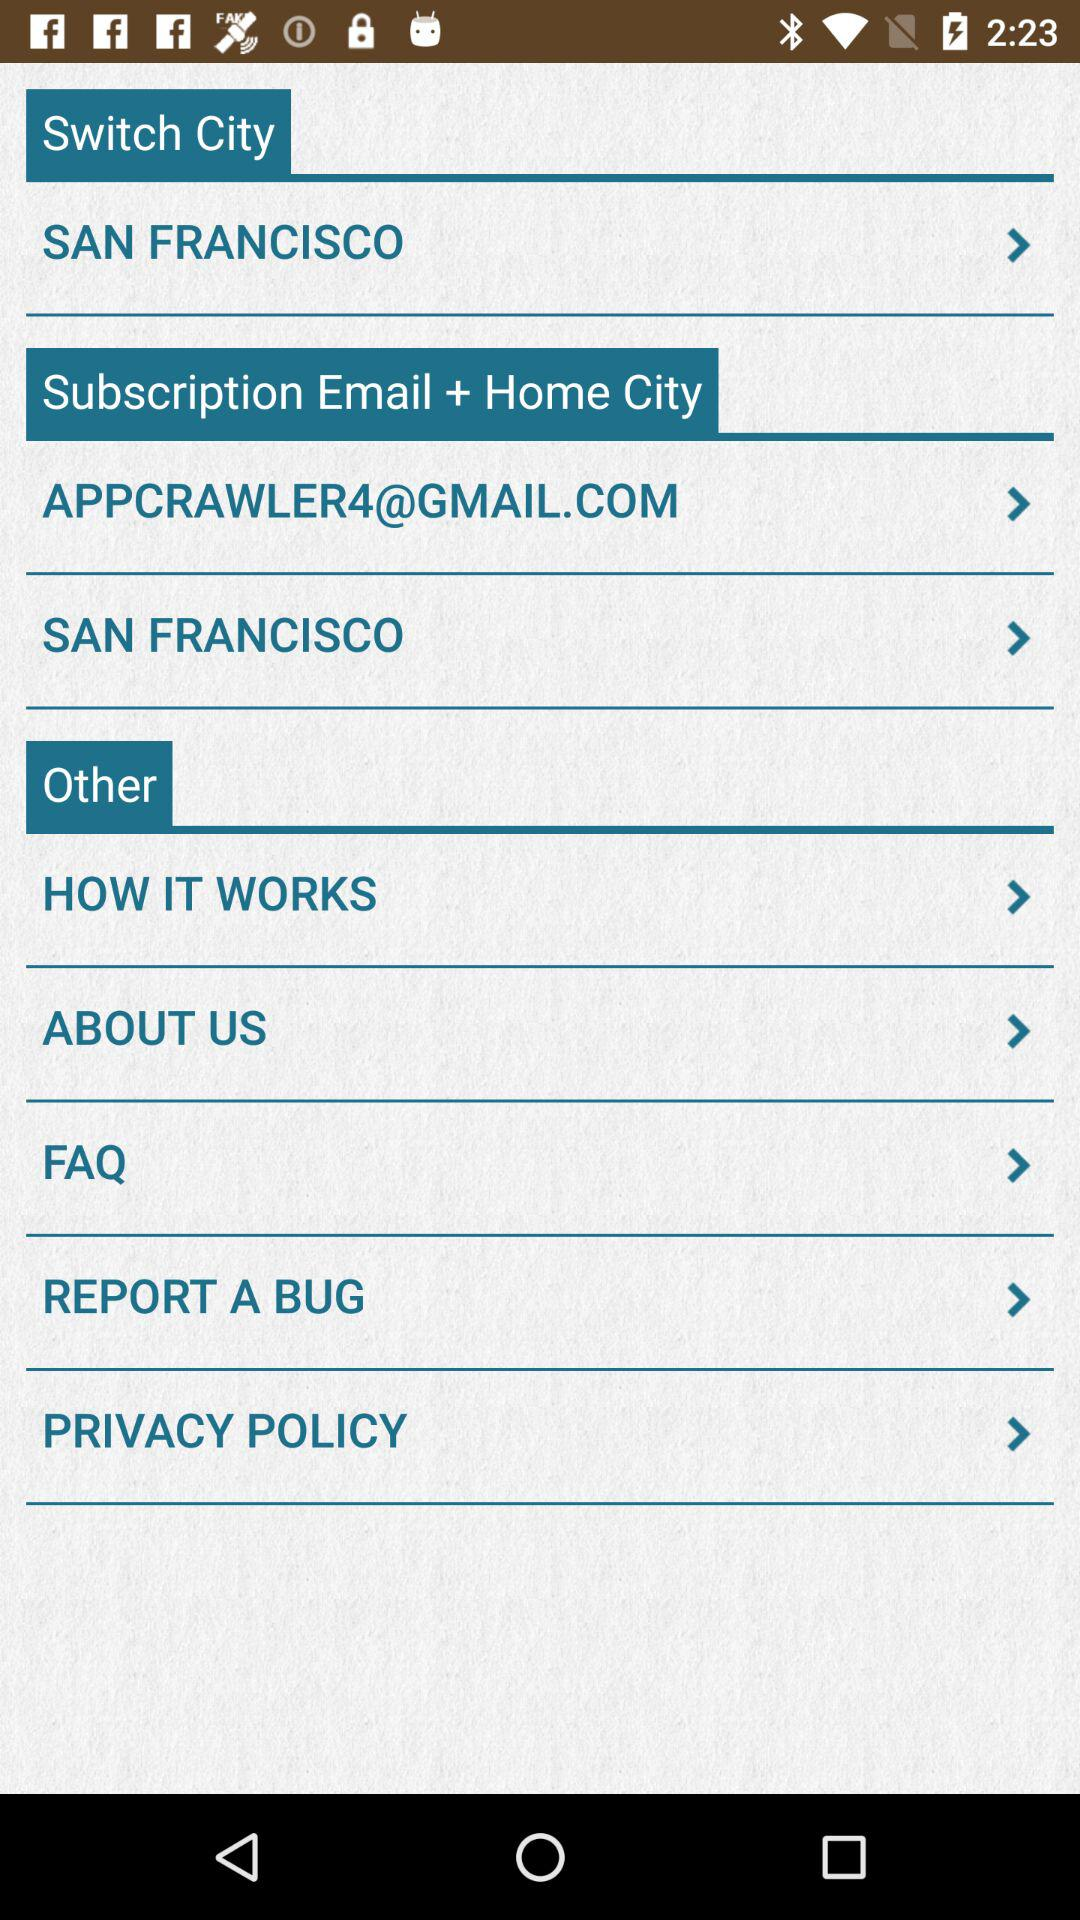What is the subscription email address? The subscription email address is appcrawler4@gmail.com. 